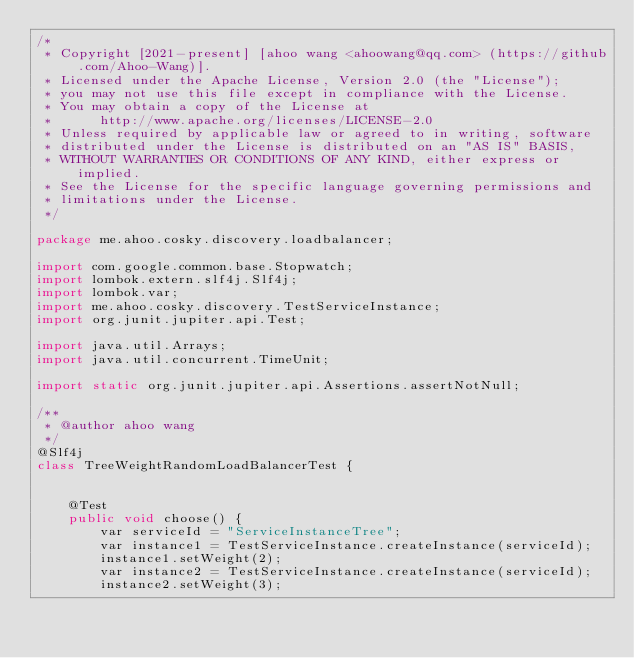Convert code to text. <code><loc_0><loc_0><loc_500><loc_500><_Java_>/*
 * Copyright [2021-present] [ahoo wang <ahoowang@qq.com> (https://github.com/Ahoo-Wang)].
 * Licensed under the Apache License, Version 2.0 (the "License");
 * you may not use this file except in compliance with the License.
 * You may obtain a copy of the License at
 *      http://www.apache.org/licenses/LICENSE-2.0
 * Unless required by applicable law or agreed to in writing, software
 * distributed under the License is distributed on an "AS IS" BASIS,
 * WITHOUT WARRANTIES OR CONDITIONS OF ANY KIND, either express or implied.
 * See the License for the specific language governing permissions and
 * limitations under the License.
 */

package me.ahoo.cosky.discovery.loadbalancer;

import com.google.common.base.Stopwatch;
import lombok.extern.slf4j.Slf4j;
import lombok.var;
import me.ahoo.cosky.discovery.TestServiceInstance;
import org.junit.jupiter.api.Test;

import java.util.Arrays;
import java.util.concurrent.TimeUnit;

import static org.junit.jupiter.api.Assertions.assertNotNull;

/**
 * @author ahoo wang
 */
@Slf4j
class TreeWeightRandomLoadBalancerTest {


    @Test
    public void choose() {
        var serviceId = "ServiceInstanceTree";
        var instance1 = TestServiceInstance.createInstance(serviceId);
        instance1.setWeight(2);
        var instance2 = TestServiceInstance.createInstance(serviceId);
        instance2.setWeight(3);</code> 